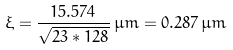Convert formula to latex. <formula><loc_0><loc_0><loc_500><loc_500>\xi = { \frac { 1 5 . 5 7 4 } { \sqrt { 2 3 * 1 2 8 } } } \, \mu m = 0 . 2 8 7 \, \mu m</formula> 